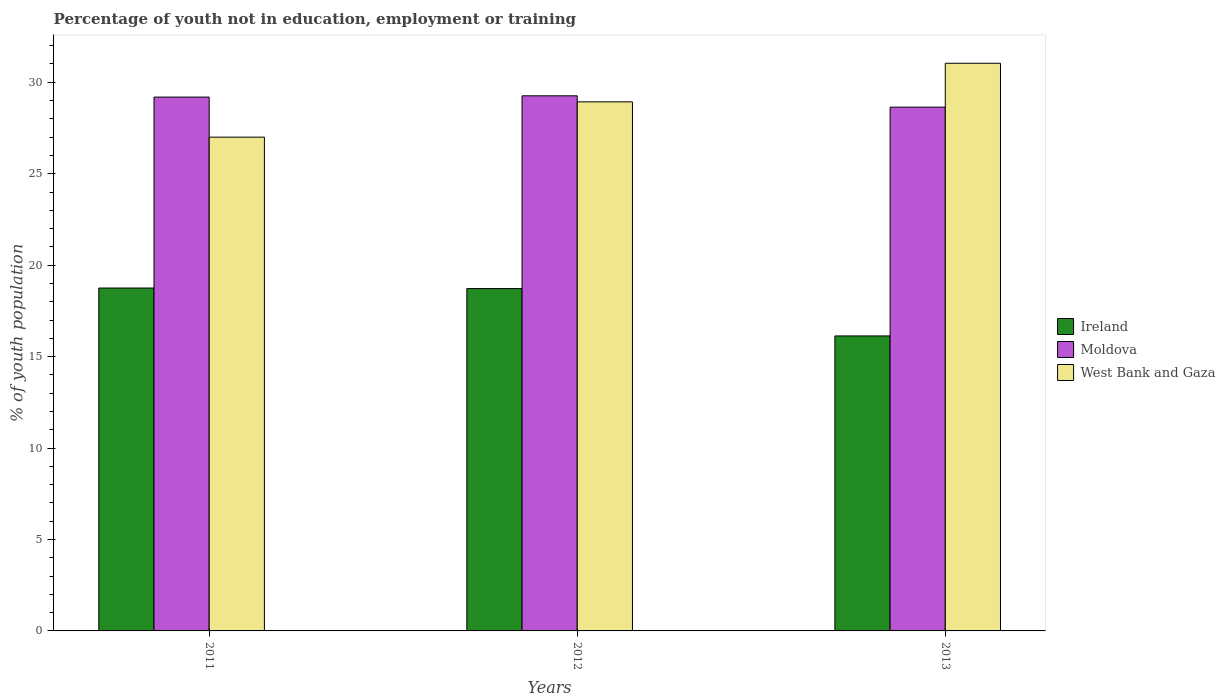How many different coloured bars are there?
Provide a short and direct response. 3. Are the number of bars on each tick of the X-axis equal?
Make the answer very short. Yes. How many bars are there on the 2nd tick from the left?
Your answer should be very brief. 3. How many bars are there on the 3rd tick from the right?
Keep it short and to the point. 3. What is the percentage of unemployed youth population in in Ireland in 2012?
Ensure brevity in your answer.  18.72. Across all years, what is the maximum percentage of unemployed youth population in in Ireland?
Provide a succinct answer. 18.75. Across all years, what is the minimum percentage of unemployed youth population in in Ireland?
Offer a very short reply. 16.13. What is the total percentage of unemployed youth population in in Ireland in the graph?
Ensure brevity in your answer.  53.6. What is the difference between the percentage of unemployed youth population in in Moldova in 2011 and that in 2013?
Your response must be concise. 0.55. What is the difference between the percentage of unemployed youth population in in Moldova in 2011 and the percentage of unemployed youth population in in Ireland in 2013?
Your answer should be compact. 13.06. What is the average percentage of unemployed youth population in in West Bank and Gaza per year?
Offer a terse response. 28.99. In the year 2011, what is the difference between the percentage of unemployed youth population in in Ireland and percentage of unemployed youth population in in Moldova?
Offer a terse response. -10.44. In how many years, is the percentage of unemployed youth population in in West Bank and Gaza greater than 30 %?
Offer a terse response. 1. What is the ratio of the percentage of unemployed youth population in in West Bank and Gaza in 2011 to that in 2013?
Keep it short and to the point. 0.87. Is the percentage of unemployed youth population in in Moldova in 2012 less than that in 2013?
Provide a succinct answer. No. Is the difference between the percentage of unemployed youth population in in Ireland in 2011 and 2012 greater than the difference between the percentage of unemployed youth population in in Moldova in 2011 and 2012?
Provide a short and direct response. Yes. What is the difference between the highest and the second highest percentage of unemployed youth population in in West Bank and Gaza?
Make the answer very short. 2.11. What is the difference between the highest and the lowest percentage of unemployed youth population in in West Bank and Gaza?
Ensure brevity in your answer.  4.04. What does the 2nd bar from the left in 2012 represents?
Your answer should be very brief. Moldova. What does the 2nd bar from the right in 2013 represents?
Keep it short and to the point. Moldova. Is it the case that in every year, the sum of the percentage of unemployed youth population in in Ireland and percentage of unemployed youth population in in West Bank and Gaza is greater than the percentage of unemployed youth population in in Moldova?
Your answer should be compact. Yes. Are all the bars in the graph horizontal?
Offer a very short reply. No. How many years are there in the graph?
Your response must be concise. 3. What is the difference between two consecutive major ticks on the Y-axis?
Make the answer very short. 5. Are the values on the major ticks of Y-axis written in scientific E-notation?
Keep it short and to the point. No. Does the graph contain any zero values?
Your answer should be very brief. No. How many legend labels are there?
Provide a succinct answer. 3. What is the title of the graph?
Give a very brief answer. Percentage of youth not in education, employment or training. What is the label or title of the Y-axis?
Provide a succinct answer. % of youth population. What is the % of youth population in Ireland in 2011?
Ensure brevity in your answer.  18.75. What is the % of youth population in Moldova in 2011?
Offer a terse response. 29.19. What is the % of youth population in West Bank and Gaza in 2011?
Provide a succinct answer. 27. What is the % of youth population of Ireland in 2012?
Provide a short and direct response. 18.72. What is the % of youth population in Moldova in 2012?
Your answer should be compact. 29.26. What is the % of youth population of West Bank and Gaza in 2012?
Provide a short and direct response. 28.93. What is the % of youth population in Ireland in 2013?
Ensure brevity in your answer.  16.13. What is the % of youth population in Moldova in 2013?
Provide a short and direct response. 28.64. What is the % of youth population of West Bank and Gaza in 2013?
Your response must be concise. 31.04. Across all years, what is the maximum % of youth population of Ireland?
Offer a very short reply. 18.75. Across all years, what is the maximum % of youth population of Moldova?
Ensure brevity in your answer.  29.26. Across all years, what is the maximum % of youth population in West Bank and Gaza?
Your answer should be very brief. 31.04. Across all years, what is the minimum % of youth population of Ireland?
Offer a terse response. 16.13. Across all years, what is the minimum % of youth population of Moldova?
Keep it short and to the point. 28.64. What is the total % of youth population in Ireland in the graph?
Make the answer very short. 53.6. What is the total % of youth population of Moldova in the graph?
Provide a short and direct response. 87.09. What is the total % of youth population in West Bank and Gaza in the graph?
Give a very brief answer. 86.97. What is the difference between the % of youth population of Ireland in 2011 and that in 2012?
Keep it short and to the point. 0.03. What is the difference between the % of youth population of Moldova in 2011 and that in 2012?
Your response must be concise. -0.07. What is the difference between the % of youth population in West Bank and Gaza in 2011 and that in 2012?
Provide a succinct answer. -1.93. What is the difference between the % of youth population of Ireland in 2011 and that in 2013?
Offer a terse response. 2.62. What is the difference between the % of youth population of Moldova in 2011 and that in 2013?
Offer a terse response. 0.55. What is the difference between the % of youth population of West Bank and Gaza in 2011 and that in 2013?
Provide a succinct answer. -4.04. What is the difference between the % of youth population in Ireland in 2012 and that in 2013?
Make the answer very short. 2.59. What is the difference between the % of youth population of Moldova in 2012 and that in 2013?
Give a very brief answer. 0.62. What is the difference between the % of youth population of West Bank and Gaza in 2012 and that in 2013?
Your answer should be compact. -2.11. What is the difference between the % of youth population of Ireland in 2011 and the % of youth population of Moldova in 2012?
Make the answer very short. -10.51. What is the difference between the % of youth population in Ireland in 2011 and the % of youth population in West Bank and Gaza in 2012?
Your answer should be compact. -10.18. What is the difference between the % of youth population in Moldova in 2011 and the % of youth population in West Bank and Gaza in 2012?
Your answer should be compact. 0.26. What is the difference between the % of youth population of Ireland in 2011 and the % of youth population of Moldova in 2013?
Ensure brevity in your answer.  -9.89. What is the difference between the % of youth population in Ireland in 2011 and the % of youth population in West Bank and Gaza in 2013?
Offer a terse response. -12.29. What is the difference between the % of youth population of Moldova in 2011 and the % of youth population of West Bank and Gaza in 2013?
Your answer should be compact. -1.85. What is the difference between the % of youth population in Ireland in 2012 and the % of youth population in Moldova in 2013?
Provide a short and direct response. -9.92. What is the difference between the % of youth population in Ireland in 2012 and the % of youth population in West Bank and Gaza in 2013?
Keep it short and to the point. -12.32. What is the difference between the % of youth population of Moldova in 2012 and the % of youth population of West Bank and Gaza in 2013?
Ensure brevity in your answer.  -1.78. What is the average % of youth population in Ireland per year?
Provide a short and direct response. 17.87. What is the average % of youth population of Moldova per year?
Your answer should be very brief. 29.03. What is the average % of youth population of West Bank and Gaza per year?
Provide a short and direct response. 28.99. In the year 2011, what is the difference between the % of youth population of Ireland and % of youth population of Moldova?
Your answer should be very brief. -10.44. In the year 2011, what is the difference between the % of youth population in Ireland and % of youth population in West Bank and Gaza?
Your answer should be compact. -8.25. In the year 2011, what is the difference between the % of youth population in Moldova and % of youth population in West Bank and Gaza?
Offer a terse response. 2.19. In the year 2012, what is the difference between the % of youth population of Ireland and % of youth population of Moldova?
Provide a succinct answer. -10.54. In the year 2012, what is the difference between the % of youth population of Ireland and % of youth population of West Bank and Gaza?
Ensure brevity in your answer.  -10.21. In the year 2012, what is the difference between the % of youth population of Moldova and % of youth population of West Bank and Gaza?
Ensure brevity in your answer.  0.33. In the year 2013, what is the difference between the % of youth population in Ireland and % of youth population in Moldova?
Give a very brief answer. -12.51. In the year 2013, what is the difference between the % of youth population in Ireland and % of youth population in West Bank and Gaza?
Provide a short and direct response. -14.91. In the year 2013, what is the difference between the % of youth population of Moldova and % of youth population of West Bank and Gaza?
Give a very brief answer. -2.4. What is the ratio of the % of youth population of Ireland in 2011 to that in 2013?
Provide a succinct answer. 1.16. What is the ratio of the % of youth population of Moldova in 2011 to that in 2013?
Your answer should be very brief. 1.02. What is the ratio of the % of youth population in West Bank and Gaza in 2011 to that in 2013?
Offer a very short reply. 0.87. What is the ratio of the % of youth population of Ireland in 2012 to that in 2013?
Provide a short and direct response. 1.16. What is the ratio of the % of youth population in Moldova in 2012 to that in 2013?
Ensure brevity in your answer.  1.02. What is the ratio of the % of youth population of West Bank and Gaza in 2012 to that in 2013?
Offer a terse response. 0.93. What is the difference between the highest and the second highest % of youth population in Moldova?
Make the answer very short. 0.07. What is the difference between the highest and the second highest % of youth population of West Bank and Gaza?
Your answer should be compact. 2.11. What is the difference between the highest and the lowest % of youth population in Ireland?
Your response must be concise. 2.62. What is the difference between the highest and the lowest % of youth population of Moldova?
Provide a succinct answer. 0.62. What is the difference between the highest and the lowest % of youth population in West Bank and Gaza?
Provide a succinct answer. 4.04. 